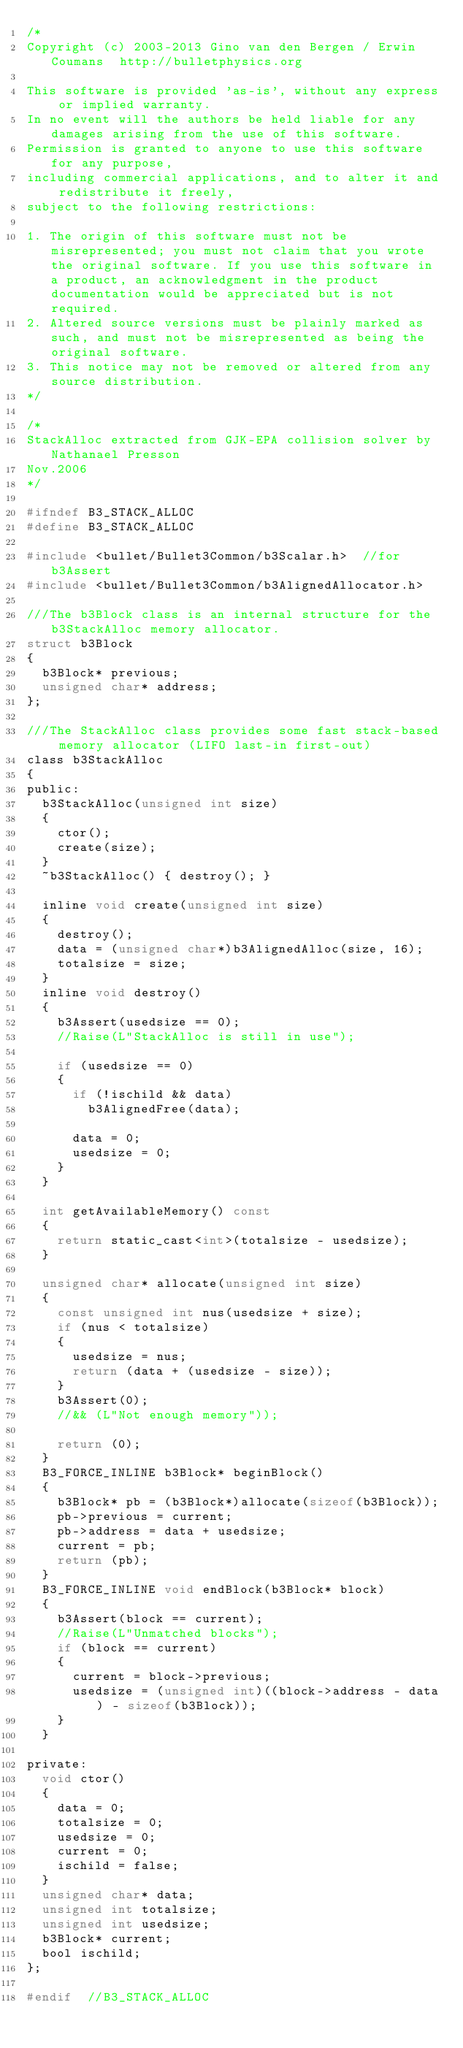<code> <loc_0><loc_0><loc_500><loc_500><_C_>/*
Copyright (c) 2003-2013 Gino van den Bergen / Erwin Coumans  http://bulletphysics.org

This software is provided 'as-is', without any express or implied warranty.
In no event will the authors be held liable for any damages arising from the use of this software.
Permission is granted to anyone to use this software for any purpose, 
including commercial applications, and to alter it and redistribute it freely, 
subject to the following restrictions:

1. The origin of this software must not be misrepresented; you must not claim that you wrote the original software. If you use this software in a product, an acknowledgment in the product documentation would be appreciated but is not required.
2. Altered source versions must be plainly marked as such, and must not be misrepresented as being the original software.
3. This notice may not be removed or altered from any source distribution.
*/

/*
StackAlloc extracted from GJK-EPA collision solver by Nathanael Presson
Nov.2006
*/

#ifndef B3_STACK_ALLOC
#define B3_STACK_ALLOC

#include <bullet/Bullet3Common/b3Scalar.h>  //for b3Assert
#include <bullet/Bullet3Common/b3AlignedAllocator.h>

///The b3Block class is an internal structure for the b3StackAlloc memory allocator.
struct b3Block
{
	b3Block* previous;
	unsigned char* address;
};

///The StackAlloc class provides some fast stack-based memory allocator (LIFO last-in first-out)
class b3StackAlloc
{
public:
	b3StackAlloc(unsigned int size)
	{
		ctor();
		create(size);
	}
	~b3StackAlloc() { destroy(); }

	inline void create(unsigned int size)
	{
		destroy();
		data = (unsigned char*)b3AlignedAlloc(size, 16);
		totalsize = size;
	}
	inline void destroy()
	{
		b3Assert(usedsize == 0);
		//Raise(L"StackAlloc is still in use");

		if (usedsize == 0)
		{
			if (!ischild && data)
				b3AlignedFree(data);

			data = 0;
			usedsize = 0;
		}
	}

	int getAvailableMemory() const
	{
		return static_cast<int>(totalsize - usedsize);
	}

	unsigned char* allocate(unsigned int size)
	{
		const unsigned int nus(usedsize + size);
		if (nus < totalsize)
		{
			usedsize = nus;
			return (data + (usedsize - size));
		}
		b3Assert(0);
		//&& (L"Not enough memory"));

		return (0);
	}
	B3_FORCE_INLINE b3Block* beginBlock()
	{
		b3Block* pb = (b3Block*)allocate(sizeof(b3Block));
		pb->previous = current;
		pb->address = data + usedsize;
		current = pb;
		return (pb);
	}
	B3_FORCE_INLINE void endBlock(b3Block* block)
	{
		b3Assert(block == current);
		//Raise(L"Unmatched blocks");
		if (block == current)
		{
			current = block->previous;
			usedsize = (unsigned int)((block->address - data) - sizeof(b3Block));
		}
	}

private:
	void ctor()
	{
		data = 0;
		totalsize = 0;
		usedsize = 0;
		current = 0;
		ischild = false;
	}
	unsigned char* data;
	unsigned int totalsize;
	unsigned int usedsize;
	b3Block* current;
	bool ischild;
};

#endif  //B3_STACK_ALLOC
</code> 